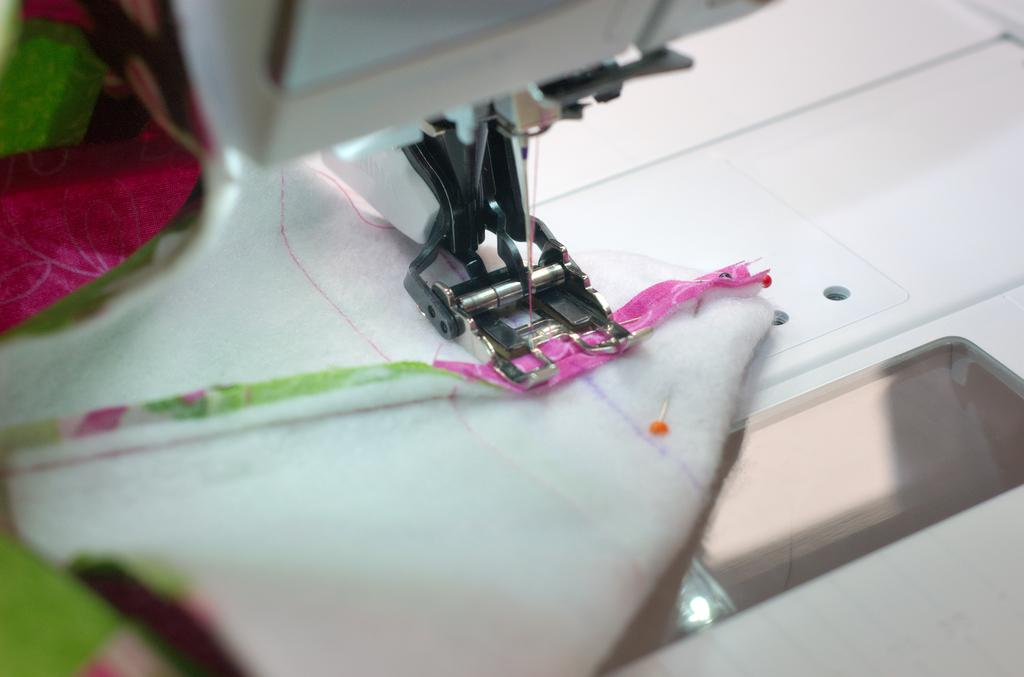What is the main object in the foreground of the image? A: There is a sewing machine in the foreground of the image. What is placed on the sewing machine? A folded cloth is present on the sewing machine. What tool is attached to the sewing machine? A needle is attached to the sewing machine. What is the rate of grain production in the image? There is no mention of grain or grain production in the image, so it is not possible to determine a rate. 